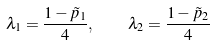Convert formula to latex. <formula><loc_0><loc_0><loc_500><loc_500>\lambda _ { 1 } = \frac { 1 - \tilde { p } _ { 1 } } { 4 } , \quad \lambda _ { 2 } = \frac { 1 - \tilde { p } _ { 2 } } { 4 }</formula> 